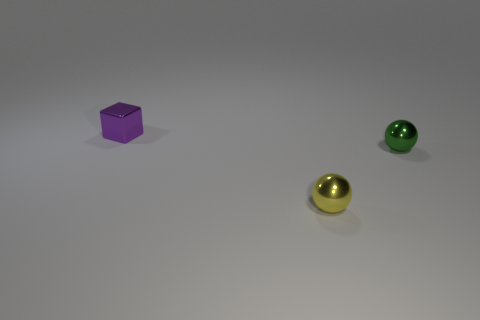Are there more small spheres that are to the right of the small green metallic sphere than tiny metal spheres that are to the left of the shiny block?
Keep it short and to the point. No. What is the color of the block?
Your response must be concise. Purple. There is a thing that is both to the left of the tiny green ball and right of the purple shiny thing; what is its color?
Provide a short and direct response. Yellow. There is a tiny metal ball that is in front of the object to the right of the yellow shiny object that is in front of the small green metal ball; what is its color?
Your answer should be compact. Yellow. There is a block that is the same size as the green object; what is its color?
Your answer should be compact. Purple. The tiny metallic object that is to the right of the tiny shiny object that is in front of the metal ball behind the tiny yellow thing is what shape?
Provide a short and direct response. Sphere. What number of things are either tiny red spheres or metal spheres in front of the tiny metallic block?
Offer a very short reply. 2. There is a sphere that is behind the yellow thing; does it have the same size as the tiny purple object?
Your response must be concise. Yes. What is the small sphere that is in front of the green object made of?
Offer a very short reply. Metal. Are there an equal number of cubes that are in front of the tiny purple thing and cubes that are in front of the green ball?
Your response must be concise. Yes. 